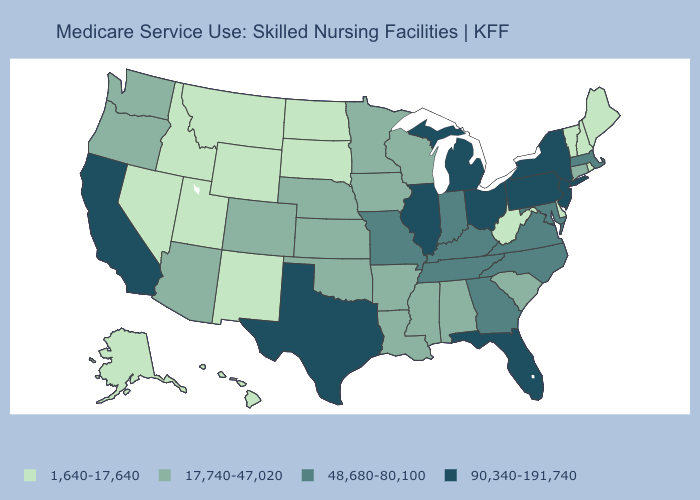Which states have the lowest value in the West?
Quick response, please. Alaska, Hawaii, Idaho, Montana, Nevada, New Mexico, Utah, Wyoming. Among the states that border Massachusetts , does Rhode Island have the highest value?
Answer briefly. No. What is the highest value in the USA?
Answer briefly. 90,340-191,740. What is the value of Connecticut?
Be succinct. 17,740-47,020. What is the highest value in the USA?
Quick response, please. 90,340-191,740. Among the states that border Massachusetts , does New Hampshire have the lowest value?
Give a very brief answer. Yes. Which states have the highest value in the USA?
Answer briefly. California, Florida, Illinois, Michigan, New Jersey, New York, Ohio, Pennsylvania, Texas. Does Montana have the lowest value in the USA?
Quick response, please. Yes. Does New York have the highest value in the Northeast?
Write a very short answer. Yes. Does North Carolina have the lowest value in the South?
Give a very brief answer. No. Does the first symbol in the legend represent the smallest category?
Concise answer only. Yes. Does the map have missing data?
Keep it brief. No. Among the states that border New Mexico , does Colorado have the highest value?
Keep it brief. No. Name the states that have a value in the range 17,740-47,020?
Write a very short answer. Alabama, Arizona, Arkansas, Colorado, Connecticut, Iowa, Kansas, Louisiana, Minnesota, Mississippi, Nebraska, Oklahoma, Oregon, South Carolina, Washington, Wisconsin. Does Florida have the lowest value in the USA?
Answer briefly. No. 